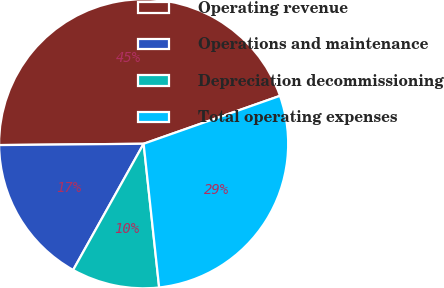Convert chart. <chart><loc_0><loc_0><loc_500><loc_500><pie_chart><fcel>Operating revenue<fcel>Operations and maintenance<fcel>Depreciation decommissioning<fcel>Total operating expenses<nl><fcel>44.77%<fcel>16.75%<fcel>9.82%<fcel>28.67%<nl></chart> 